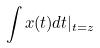Convert formula to latex. <formula><loc_0><loc_0><loc_500><loc_500>\int x ( t ) d t | _ { t = z }</formula> 